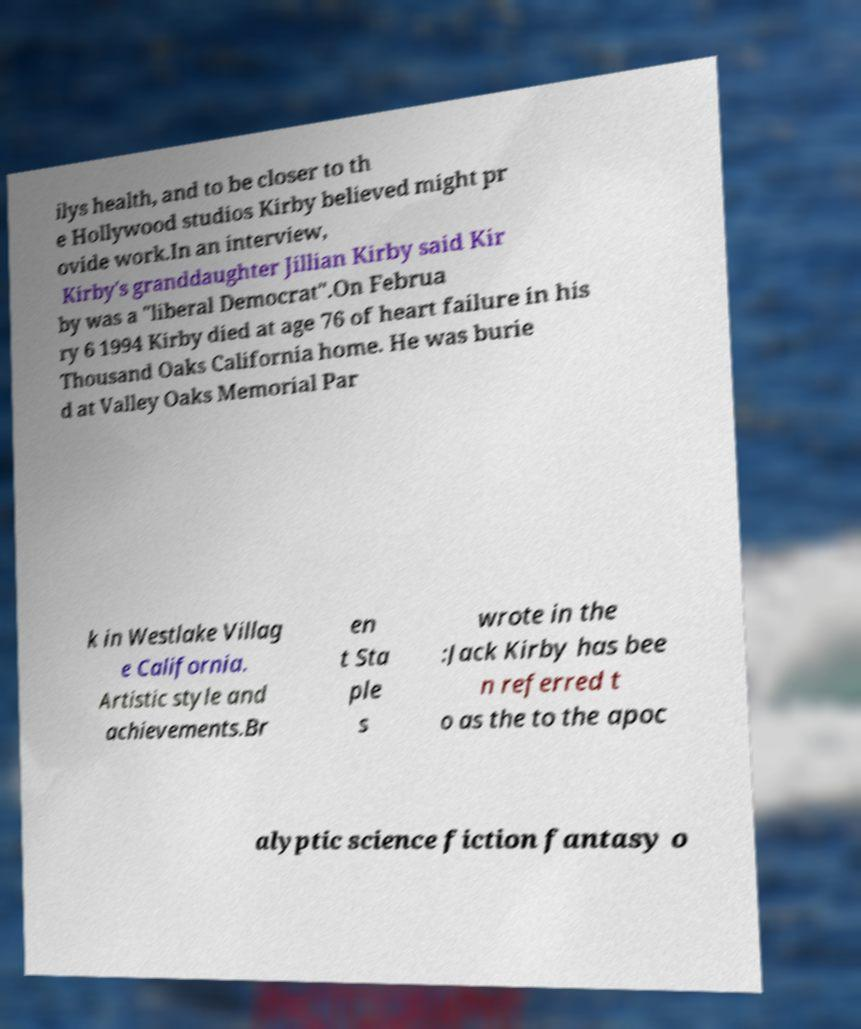Can you accurately transcribe the text from the provided image for me? ilys health, and to be closer to th e Hollywood studios Kirby believed might pr ovide work.In an interview, Kirby's granddaughter Jillian Kirby said Kir by was a "liberal Democrat".On Februa ry 6 1994 Kirby died at age 76 of heart failure in his Thousand Oaks California home. He was burie d at Valley Oaks Memorial Par k in Westlake Villag e California. Artistic style and achievements.Br en t Sta ple s wrote in the :Jack Kirby has bee n referred t o as the to the apoc alyptic science fiction fantasy o 